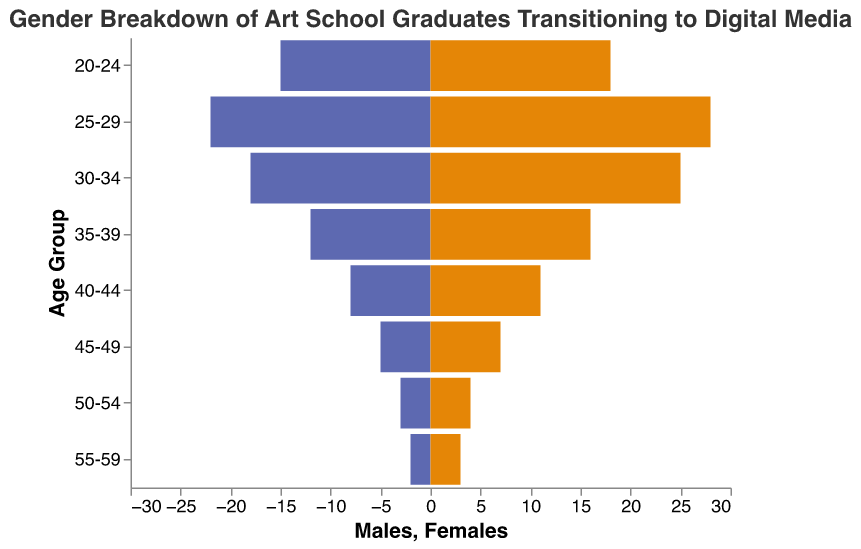What are the age groups displayed in the plot? The plot displays age groups along the Y-axis, listing ages from "20-24" to "55-59".
Answer: 20-24, 25-29, 30-34, 35-39, 40-44, 45-49, 50-54, 55-59 How many males in the age group 30-34 transitioned to digital media? The bar chart shows negative values for males, indicating 18 males in the age group 30-34.
Answer: 18 Which age group has the highest number of females? By checking the lengths of the bars on the female side, the age group 25-29 has the longest bar with 28 females.
Answer: 25-29 What is the total number of females aged between 20-29? Adding the values of females in age groups 20-24 (18) and 25-29 (28), we get 18 + 28 = 46.
Answer: 46 Compare the number of males and females in the age group 35-39: which gender has more graduates? For the age group 35-39, there are 12 males and 16 females. Females (16) are greater than males (12).
Answer: Females What is the combined total of males and females in the age group 55-59? Adding the values, we find there are 2 males and 3 females, giving a total of 2 + 3 = 5.
Answer: 5 In which age group is the gender gap (difference between males and females) the greatest? Comparing the absolute differences between males and females for each age group, the greatest difference is in the age group 25-29 (28 - 22 = 6).
Answer: 25-29 How does the number of males aged 45-49 compare to 50-54? The plot shows 5 males in age group 45-49 and 3 males in age group 50-54, meaning there are more males in the 45-49 group.
Answer: 45-49 What is the ratio of females to males in the age group 25-29? There are 28 females and 22 males in the age group 25-29. The ratio is 28:22, which simplifies to 14:11.
Answer: 14:11 